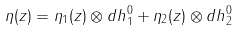<formula> <loc_0><loc_0><loc_500><loc_500>\eta ( z ) = \eta _ { 1 } ( z ) \otimes d h ^ { 0 } _ { 1 } + \eta _ { 2 } ( z ) \otimes d h ^ { 0 } _ { 2 }</formula> 